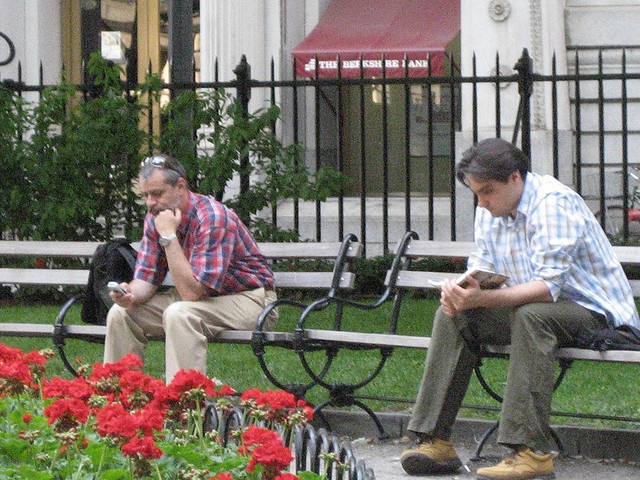Describe the objects in this image and their specific colors. I can see bench in lightgray, gray, black, and darkgreen tones, people in lightgray, gray, lavender, black, and darkgray tones, people in lightgray, darkgray, gray, and pink tones, backpack in lightgray, black, gray, and darkgray tones, and bicycle in lightgray, gray, darkgray, black, and brown tones in this image. 